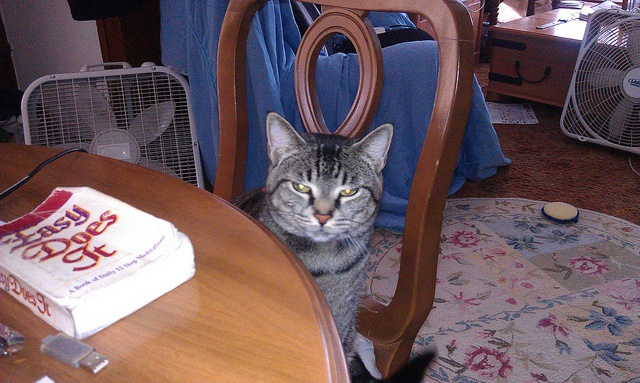Describe the objects in this image and their specific colors. I can see dining table in purple, white, brown, tan, and maroon tones, chair in purple, maroon, navy, black, and brown tones, book in purple, white, brown, darkgray, and lightpink tones, and cat in purple, gray, darkgray, and black tones in this image. 